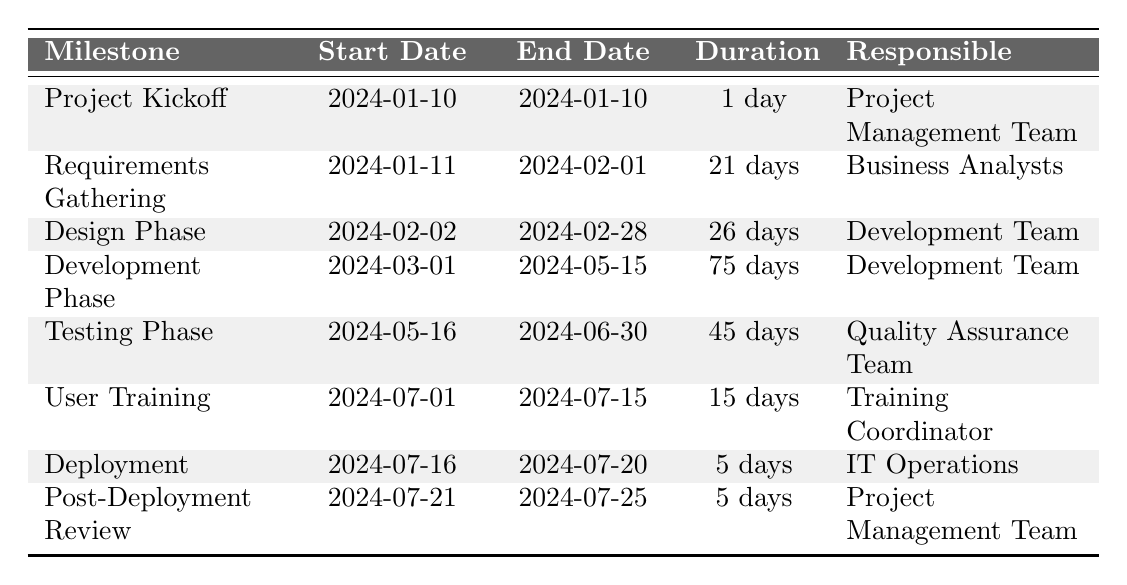What is the duration of the Development Phase? The Development Phase is listed in the table with a duration of 75 days.
Answer: 75 days What team is responsible for the User Training? In the table, the Team responsible for User Training is identified as the Training Coordinator.
Answer: Training Coordinator How many milestones are listed in total? To find the total number of milestones, count each row in the table. There are 8 milestones listed.
Answer: 8 What is the start date of the Testing Phase? The Testing Phase's start date, as shown in the table, is 2024-05-16.
Answer: 2024-05-16 Is the Design Phase longer than the Requirements Gathering phase? The Design Phase has a duration of 26 days and the Requirements Gathering phase has a duration of 21 days, so the Design Phase is indeed longer.
Answer: Yes What is the total duration of all phases combined? To find the total duration, sum the durations of all milestones: 1 + 21 + 26 + 75 + 45 + 15 + 5 + 5 = 187 days.
Answer: 187 days When does the Project Kickoff occur in relation to the Deployment phase? The Project Kickoff occurs on 2024-01-10, while the Deployment starts on 2024-07-16. Since January is before July, the Project Kickoff happens before Deployment.
Answer: Before Which team has two milestones assigned to it in the table? The Development Team has two milestones: the Design Phase and the Development Phase.
Answer: Development Team How many days are between the end of the User Training and the start of the Deployment? User Training ends on 2024-07-15 and Deployment starts on 2024-07-16. There is 1 day between these two milestones.
Answer: 1 day What is the duration of the Testing Phase compared to the Development Phase? The Testing Phase lasts 45 days, while the Development Phase lasts 75 days. Since 45 is less than 75, the Testing Phase is shorter.
Answer: Shorter 